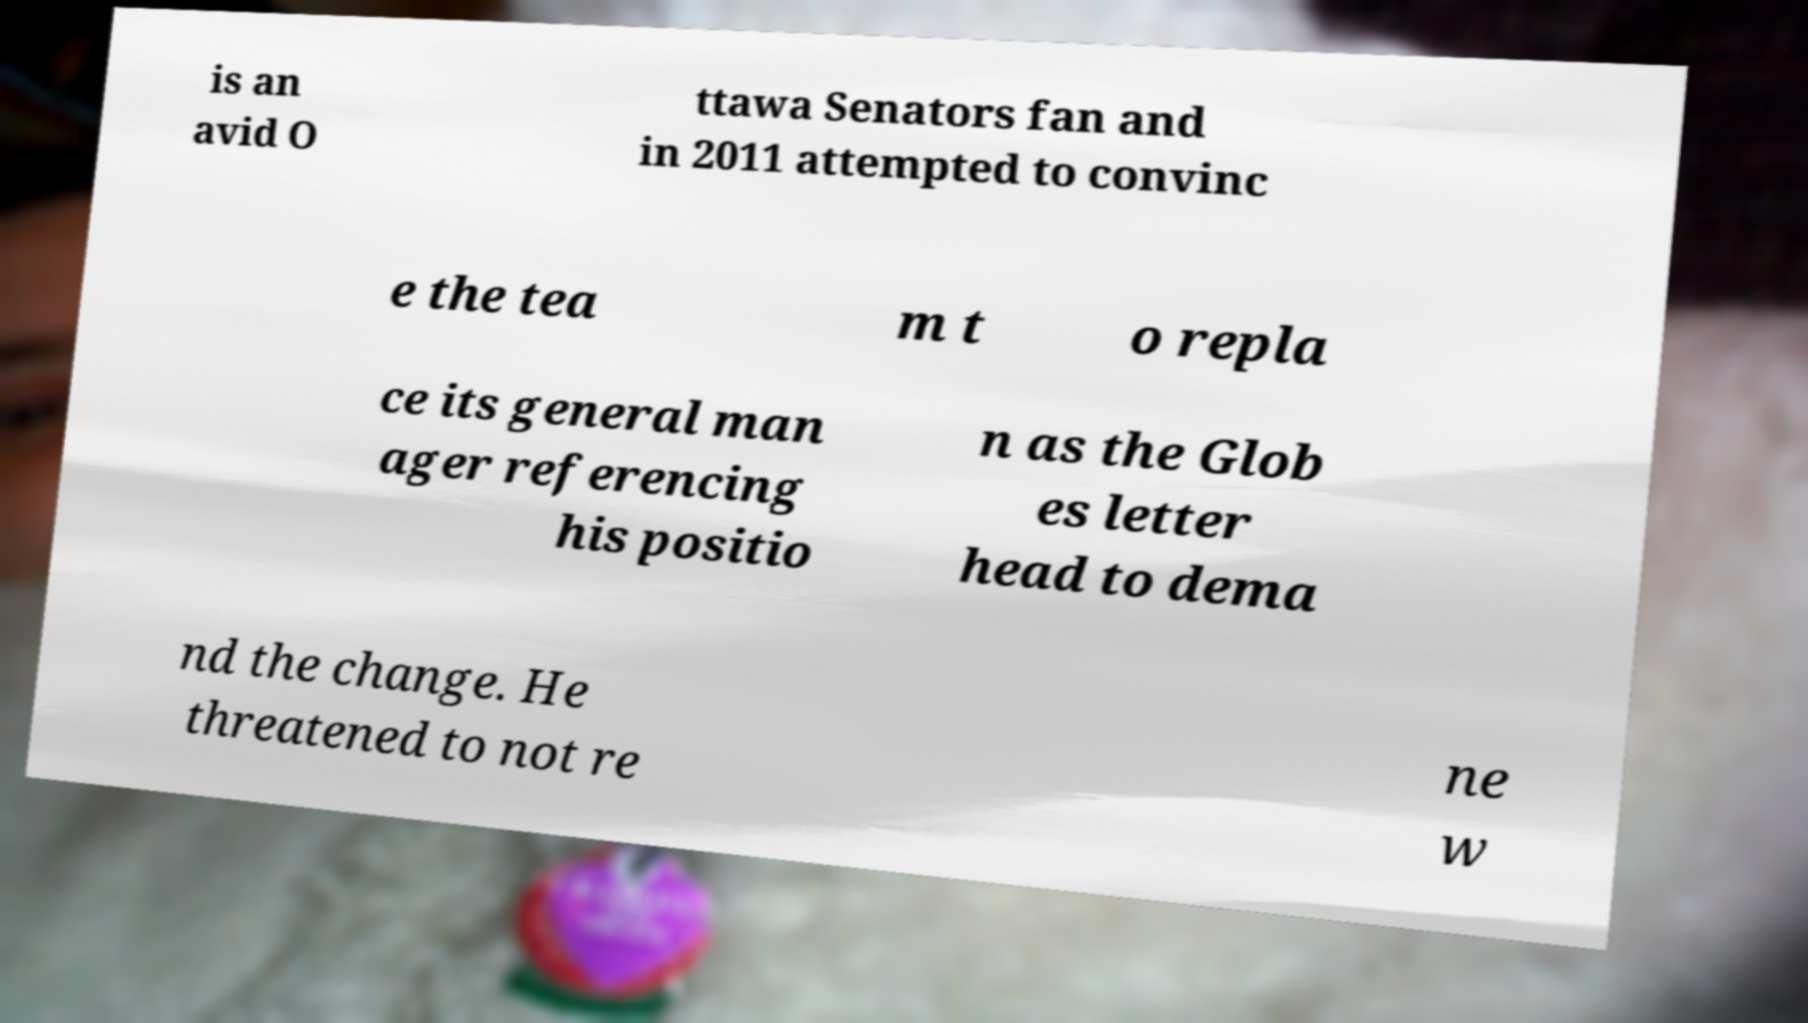Could you extract and type out the text from this image? is an avid O ttawa Senators fan and in 2011 attempted to convinc e the tea m t o repla ce its general man ager referencing his positio n as the Glob es letter head to dema nd the change. He threatened to not re ne w 